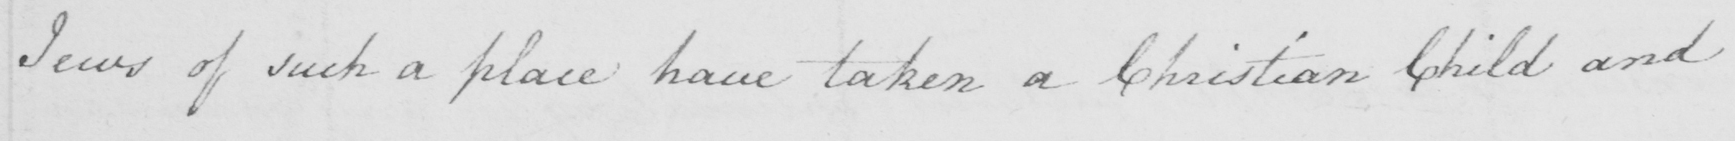Can you tell me what this handwritten text says? Jews of such a place have taken a Christian Child and 